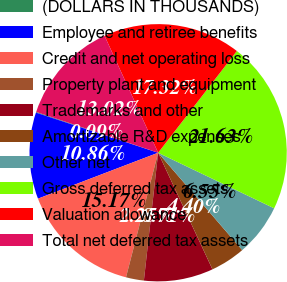<chart> <loc_0><loc_0><loc_500><loc_500><pie_chart><fcel>(DOLLARS IN THOUSANDS)<fcel>Employee and retiree benefits<fcel>Credit and net operating loss<fcel>Property plant and equipment<fcel>Trademarks and other<fcel>Amortizable R&D expenses<fcel>Other net<fcel>Gross deferred tax assets<fcel>Valuation allowance<fcel>Total net deferred tax assets<nl><fcel>0.09%<fcel>10.86%<fcel>15.17%<fcel>2.25%<fcel>8.71%<fcel>4.4%<fcel>6.55%<fcel>21.63%<fcel>17.32%<fcel>13.02%<nl></chart> 